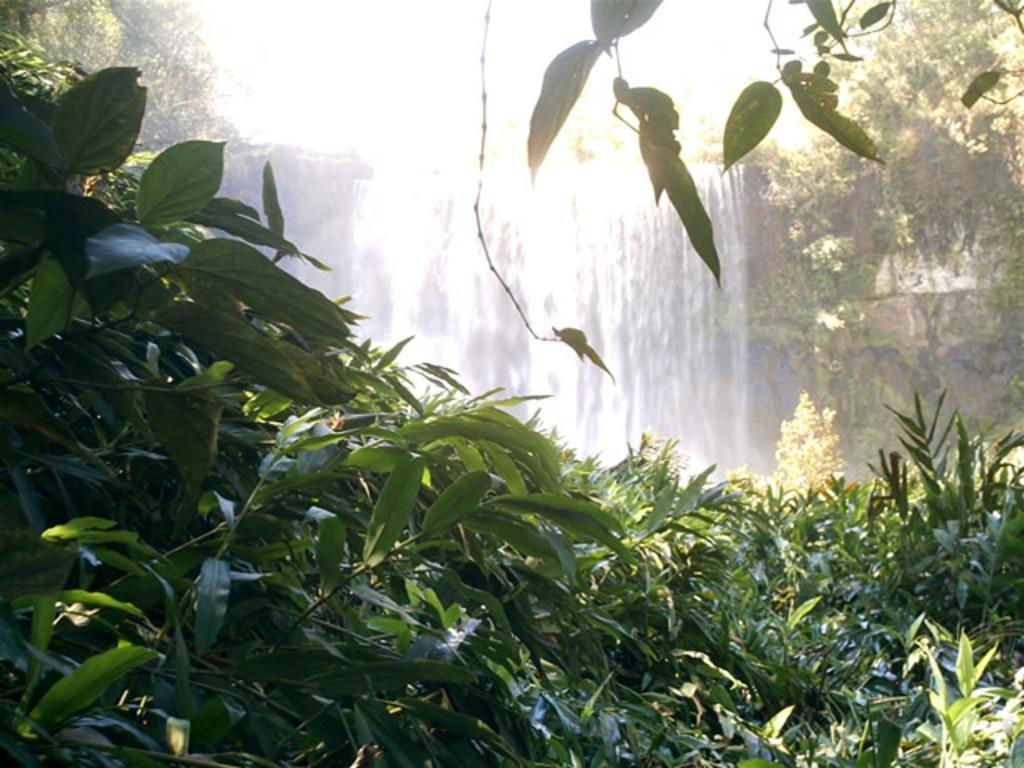Could you give a brief overview of what you see in this image? In this image we can see waterfall, plants and trees. 